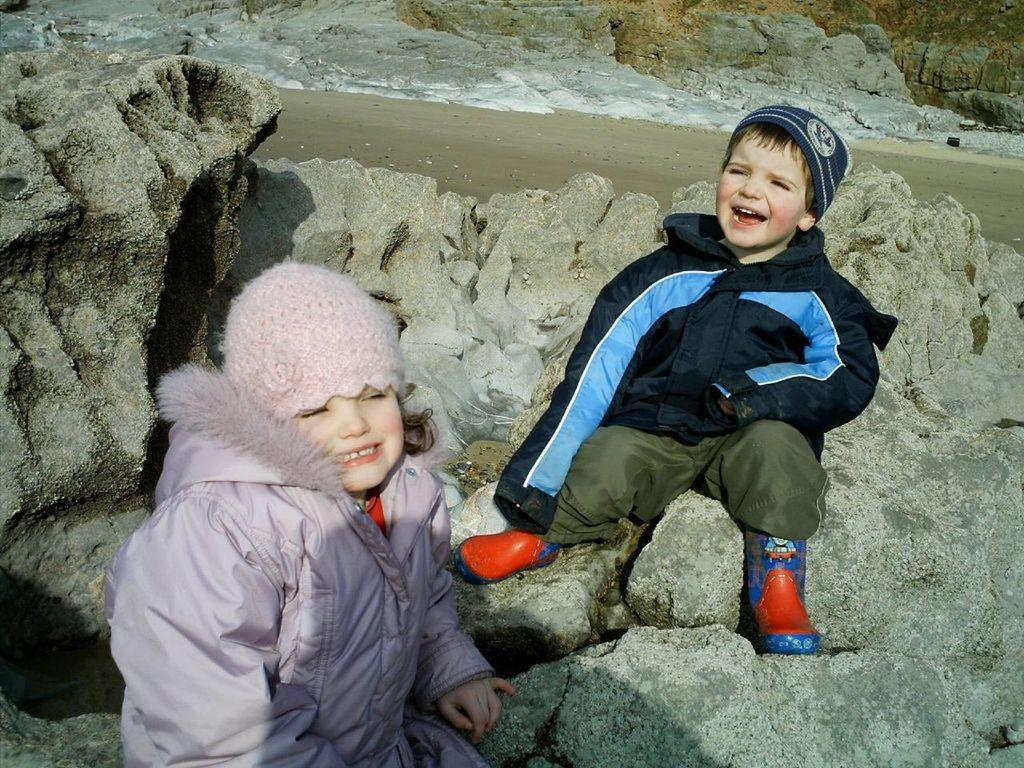How many people are in the image? There are two people in the image, a boy and a girl. What are the boy and girl wearing? Both the boy and girl are wearing jackets. Where are the boy and girl sitting? They are sitting on rocks. What type of terrain is visible in the background of the image? There is soil and water visible in the background of the image. What type of guitar is the boy playing in the image? There is no guitar present in the image; the boy and girl are sitting on rocks and wearing jackets. 